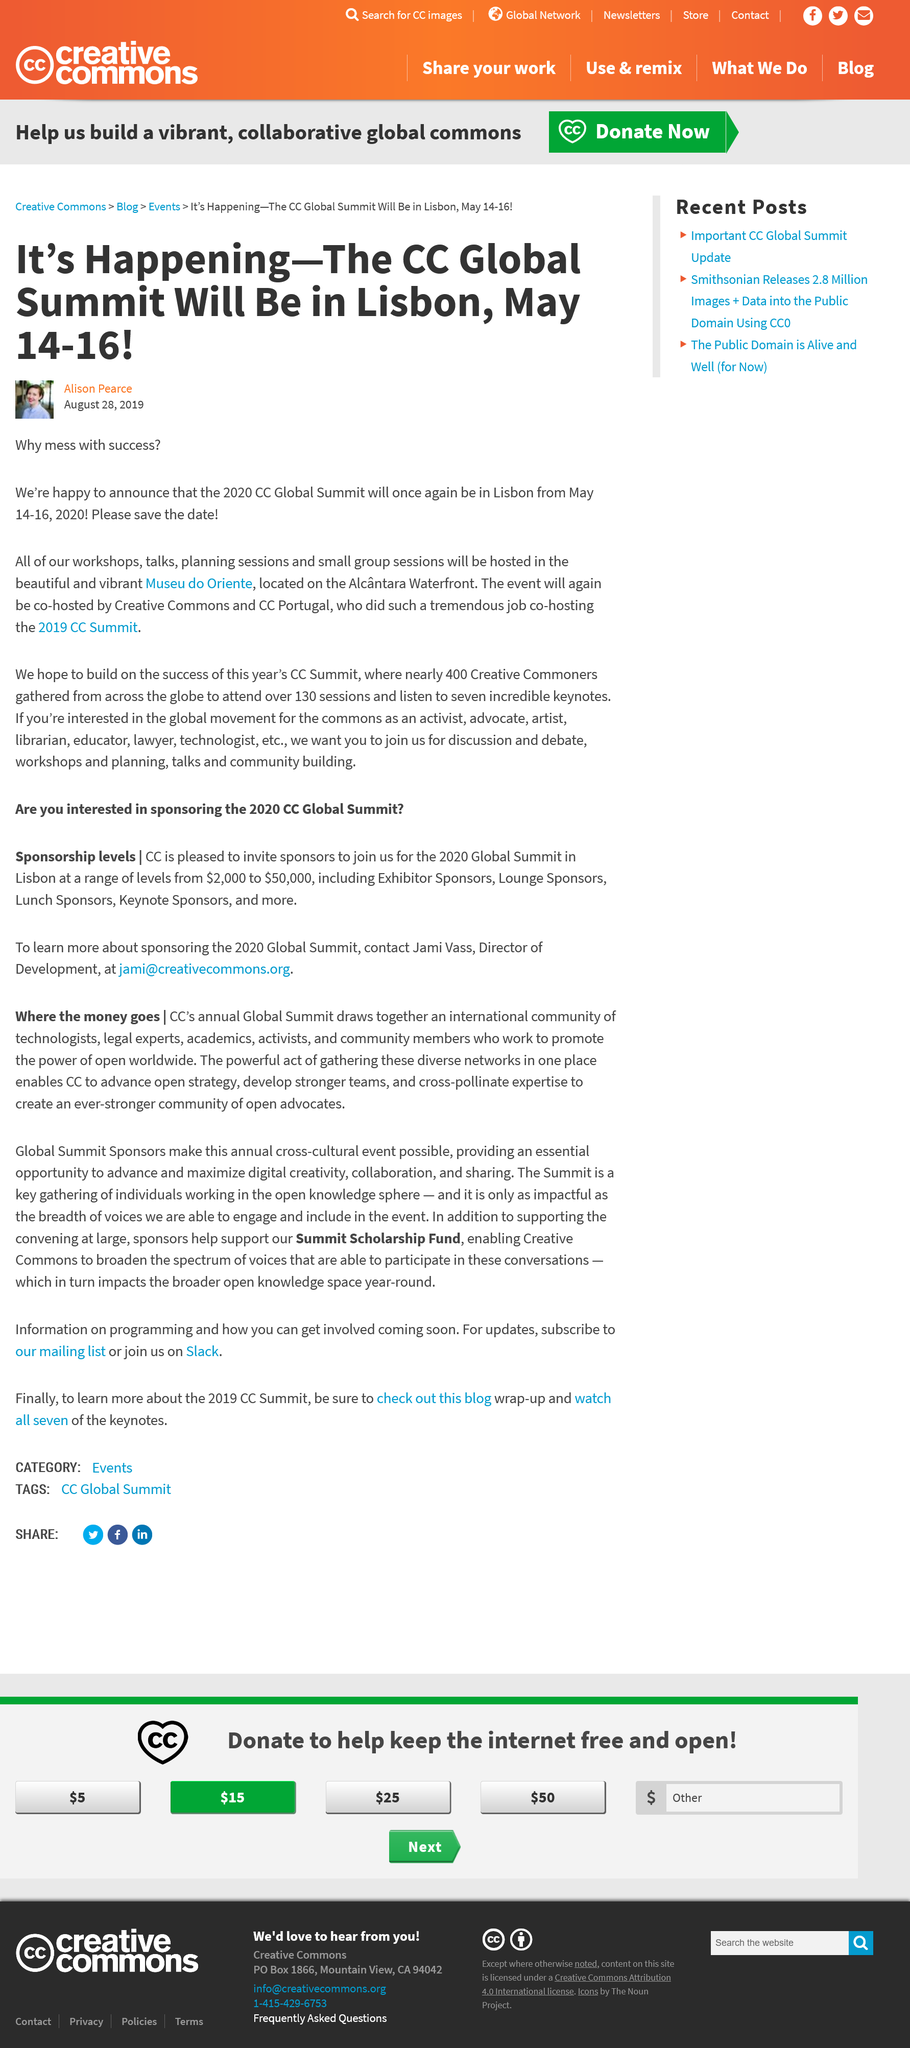Highlight a few significant elements in this photo. The CC Global Summit will take place in Lisbon at the Museu do Oriente, located on the Alcântara Waterfront, from April 11-13. The CC Summit will take place in the same city as the previous year. Yes, the CC Summit is being held in Lisbon once again. The Creative Commons Summit is being co-hosted by Creative Commons and CC Portugal in Lisbon from May 14-16. 